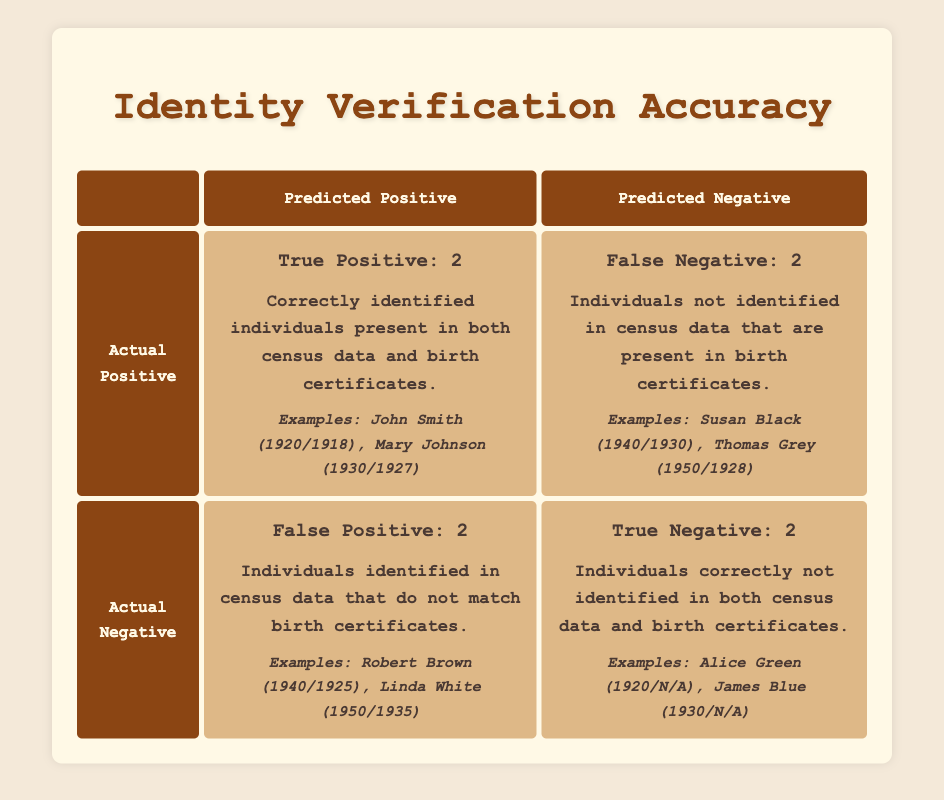What is the total count of True Positives in the table? The table shows that there are 2 True Positives listed. This count is directly referenced in the cell labeled "True Positive: 2."
Answer: 2 What examples are provided for False Negatives? The examples given in the table for False Negatives are Susan Black (1940/1930) and Thomas Grey (1950/1928), which can be found in the cell for False Negative.
Answer: Susan Black (1940/1930), Thomas Grey (1950/1928) Is there any individual identified as a True Negative? Yes, the table indicates that there are individuals correctly not identified in both datasets. The examples are Alice Green (1920/N/A) and James Blue (1930/N/A).
Answer: Yes What is the sum of True Positives and True Negatives? The True Positive count is 2, and the True Negative count is also 2. Adding these together gives 2 + 2 = 4.
Answer: 4 How many individuals are there in total who are False Positives and False Negatives combined? The table notes that there are 2 False Positives and 2 False Negatives. Adding them gives a combined total of 2 + 2 = 4.
Answer: 4 What percentage of identified individuals were True Positives? There are a total of 6 identified individuals (2 True Positives, 2 False Positives, and 2 False Negatives). The True Positive count is 2, making the percentage (2/6)*100 = 33.33%.
Answer: 33.33% What is the total number of individuals not identified in both census data and birth certificates? The table does not explicitly list individuals who are not identified in any dataset. However, it shows that there are 2 True Negatives, indicating there were 2 individuals not identified in either dataset.
Answer: 2 Which group has the highest count, True Positives or False Positives? The count of True Positives is 2 and False Positives is also 2. Therefore, neither group has a higher count as both are equal.
Answer: Neither How many examples are provided for False Positives? The table provides 2 examples for False Positives: Robert Brown (1940/1925) and Linda White (1950/1935). This information is found in the cell for False Positive.
Answer: 2 